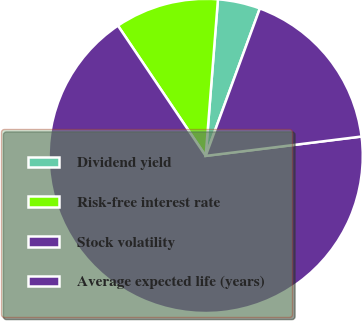Convert chart. <chart><loc_0><loc_0><loc_500><loc_500><pie_chart><fcel>Dividend yield<fcel>Risk-free interest rate<fcel>Stock volatility<fcel>Average expected life (years)<nl><fcel>4.36%<fcel>10.68%<fcel>67.54%<fcel>17.43%<nl></chart> 